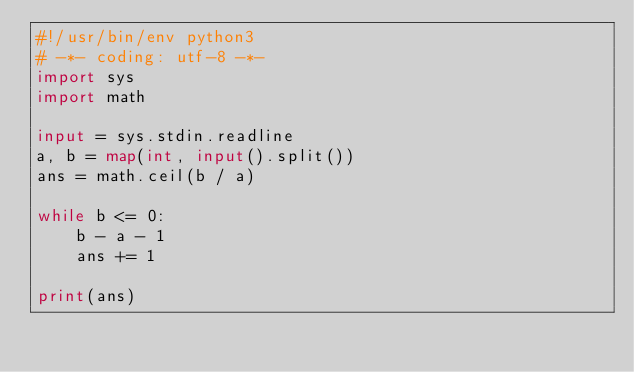Convert code to text. <code><loc_0><loc_0><loc_500><loc_500><_Python_>#!/usr/bin/env python3
# -*- coding: utf-8 -*-
import sys
import math

input = sys.stdin.readline
a, b = map(int, input().split())
ans = math.ceil(b / a)

while b <= 0:
    b - a - 1
    ans += 1

print(ans)
</code> 